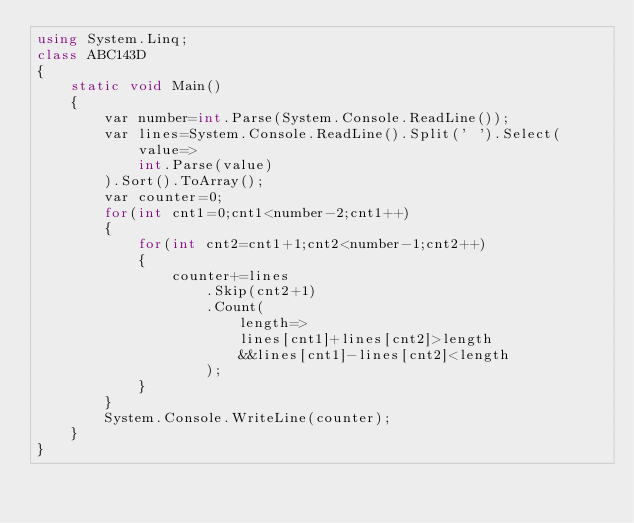Convert code to text. <code><loc_0><loc_0><loc_500><loc_500><_C#_>using System.Linq;
class ABC143D
{
    static void Main()
    {
        var number=int.Parse(System.Console.ReadLine());
        var lines=System.Console.ReadLine().Split(' ').Select(
            value=>
            int.Parse(value)
        ).Sort().ToArray();
        var counter=0;
        for(int cnt1=0;cnt1<number-2;cnt1++)
        {
            for(int cnt2=cnt1+1;cnt2<number-1;cnt2++)
            {
                counter+=lines
                    .Skip(cnt2+1)
                    .Count(
                        length=>
                        lines[cnt1]+lines[cnt2]>length
                        &&lines[cnt1]-lines[cnt2]<length
                    );
            }
        }
        System.Console.WriteLine(counter);
    }
}</code> 